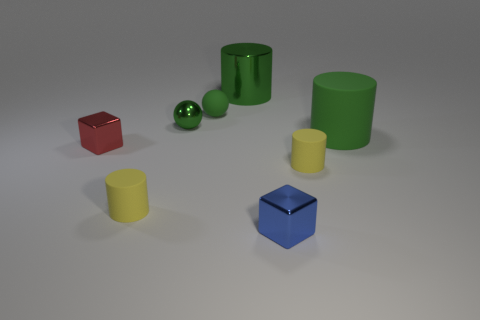Add 1 tiny green balls. How many objects exist? 9 Subtract all spheres. How many objects are left? 6 Subtract 0 blue spheres. How many objects are left? 8 Subtract all green rubber things. Subtract all tiny yellow matte things. How many objects are left? 4 Add 5 blocks. How many blocks are left? 7 Add 4 small yellow things. How many small yellow things exist? 6 